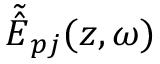<formula> <loc_0><loc_0><loc_500><loc_500>{ \tilde { \hat { E } } } _ { p j } ( z , \omega )</formula> 